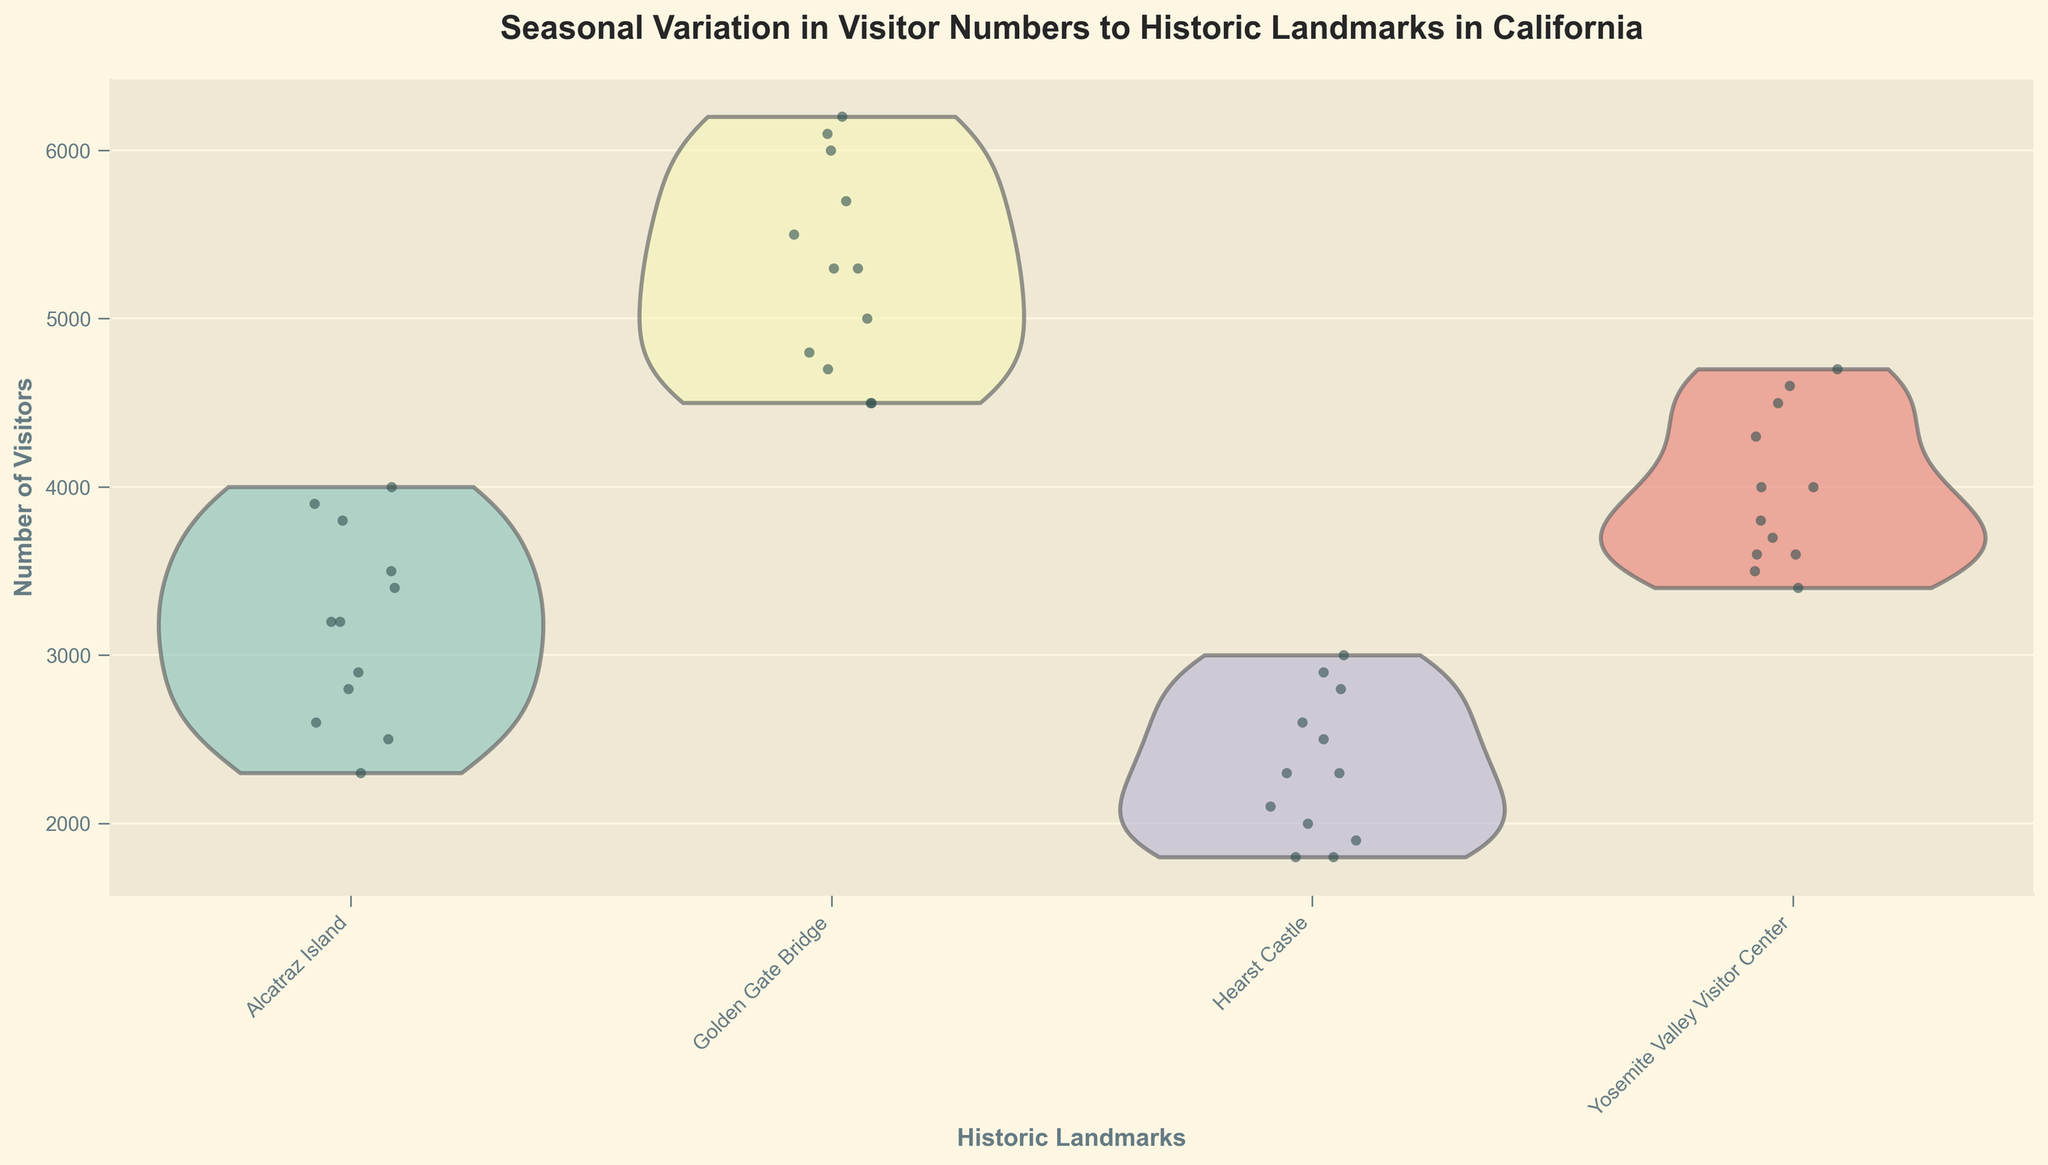What's the title of the figure? The title is usually placed at the top of the figure and describes its main subject. This figure's title is "Seasonal Variation in Visitor Numbers to Historic Landmarks in California."
Answer: Seasonal Variation in Visitor Numbers to Historic Landmarks in California Which landmark appears to have the highest visitor numbers on average? By observing the medians (central points within the violins) across the various landmarks, the Golden Gate Bridge consistently has higher median visitor numbers than other landmarks.
Answer: Golden Gate Bridge In which month does Alcatraz Island have its lowest visitor numbers based on jittered points? To determine this, we can scan the jittered points for Alcatraz Island. The lowest points are seen in January and December, with visitor numbers of around 2300 and 2500, so January is slightly lower.
Answer: January What is the rough range of visitors for Yosemite Valley Visitor Center in July? By observing the width of the violin plot and the spread of the jittered points for Yosemite in July, the visitor numbers spread from around 4500 to 4700.
Answer: 4500 to 4700 Across all landmarks, which months show an upward trend in visitor numbers? Analyzing the violin plots and jittered points for each landmark from one month to the next, visitor numbers generally increase steadily from January to July and then peak in July, before gradually decreasing.
Answer: January to July How does the spread of visitors for the Golden Gate Bridge in March compare to December? Comparing the width of the violin plots and range of jittered points, March has visitor numbers ranging from approximately 4800 to 5000, while December ranges from 4400 to 4600. The spread is somewhat similar, but December's numbers are slightly lower.
Answer: March has a similar spread but higher visitor numbers than December Which landmark shows the biggest change in visitor numbers between June and July? By comparing the changes in the width of the violin plots and jittered points, Hearst Castle shows an increase from about 2800 in June to 3000 in July, which is more notable than changes in other landmarks.
Answer: Hearst Castle What's the color distribution for the violin plots, and what can be the purpose of using different colors? The violin plots use varied, soft pastel colors from the Set3 palette, which help distinguish between different landmarks without being too visually aggressive.
Answer: Varied pastel colors to distinguish landmarks Is there any landmark that shows a consistent range of visitor numbers across all months? By comparing the width and spread of the violin plots and jittered points, Golden Gate Bridge consistently shows a higher and more stable visitor number range across all months.
Answer: Golden Gate Bridge 